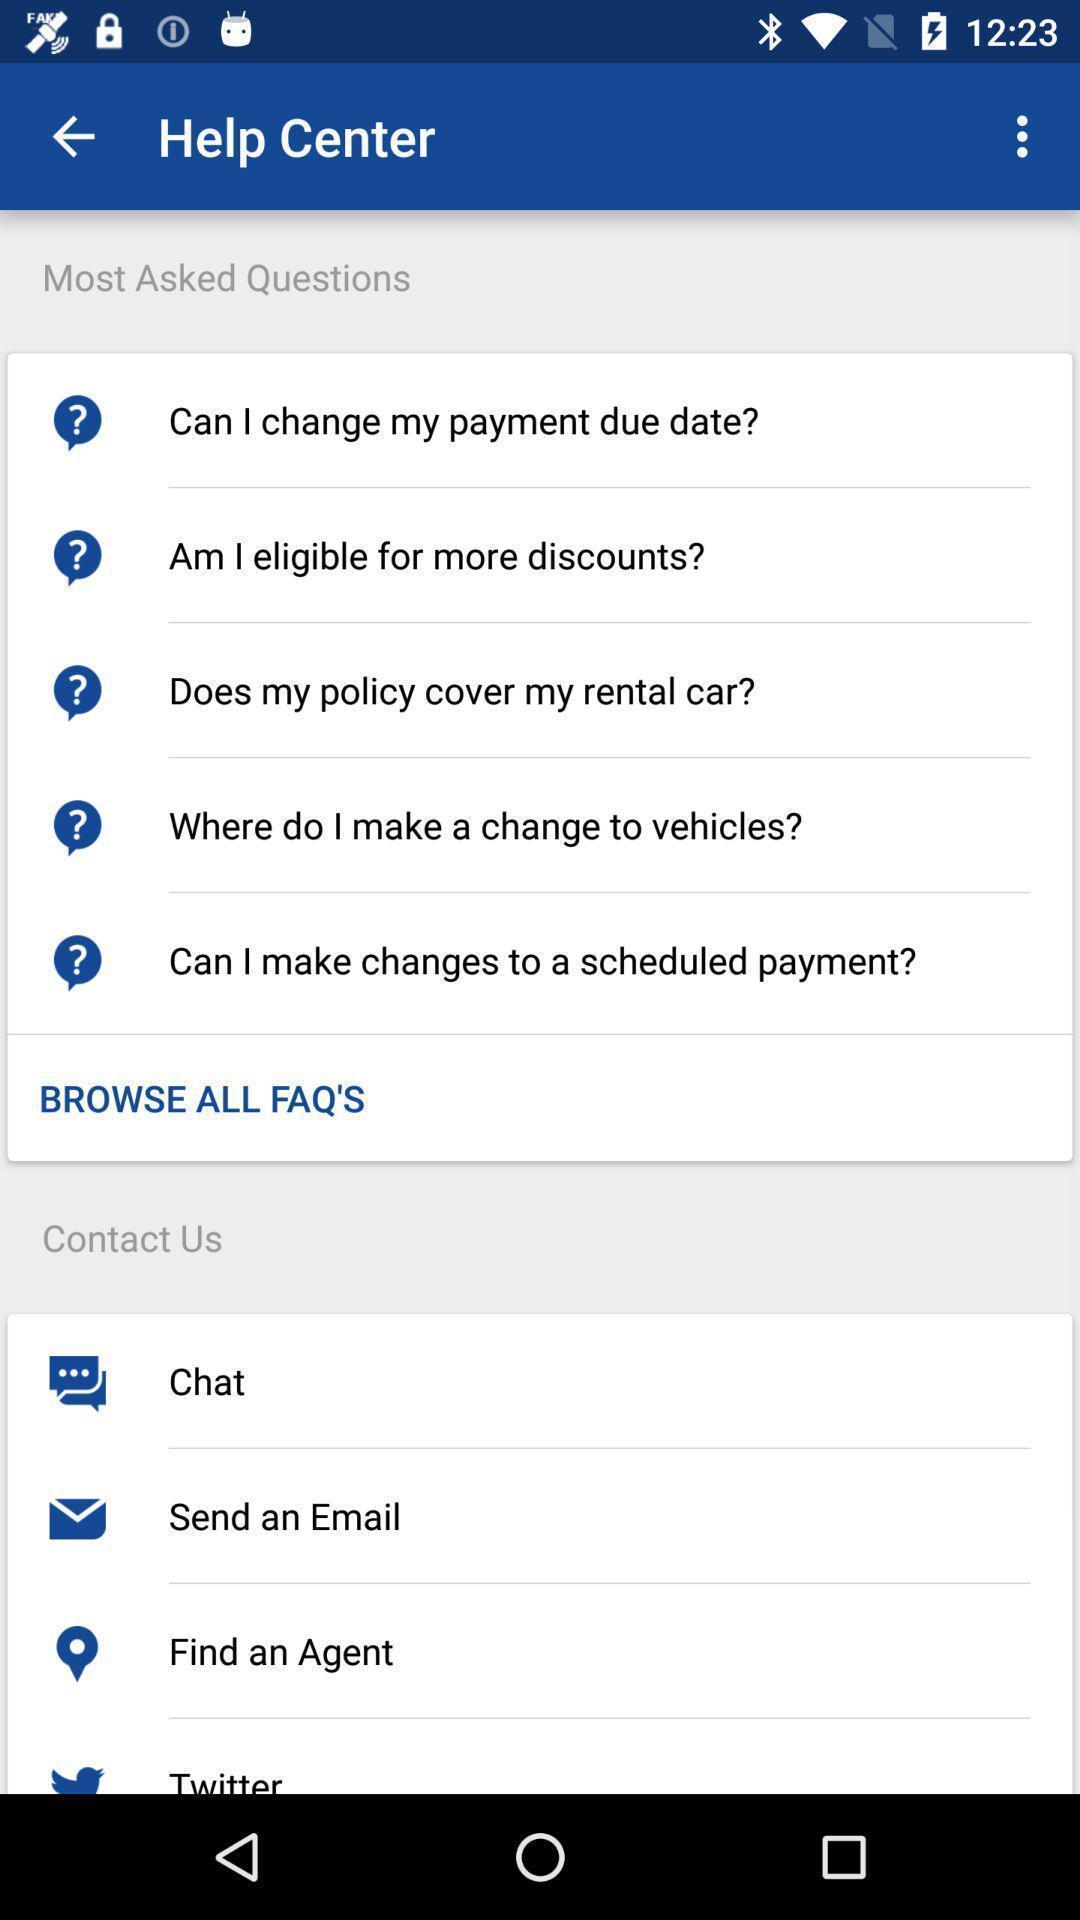What details can you identify in this image? Screen showing help center page. 